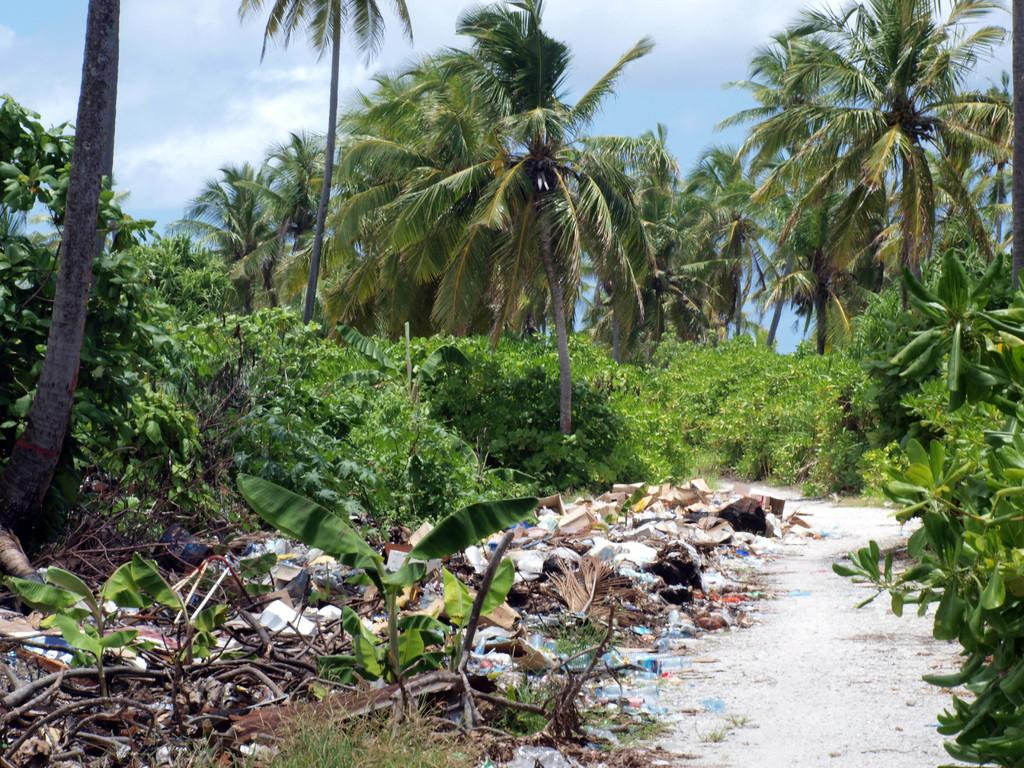What can be seen on the right side of the image? There is a path on the right side of the image. What surrounds the path in the image? Trees and plants are present on either side of the path. What is visible in the sky in the image? The sky is visible in the image, and clouds are present in the sky. How many horses are grazing in the harbor in the image? There are no horses or harbor present in the image. What type of banana can be seen hanging from the trees in the image? There are no bananas visible in the image; only trees and plants are present. 